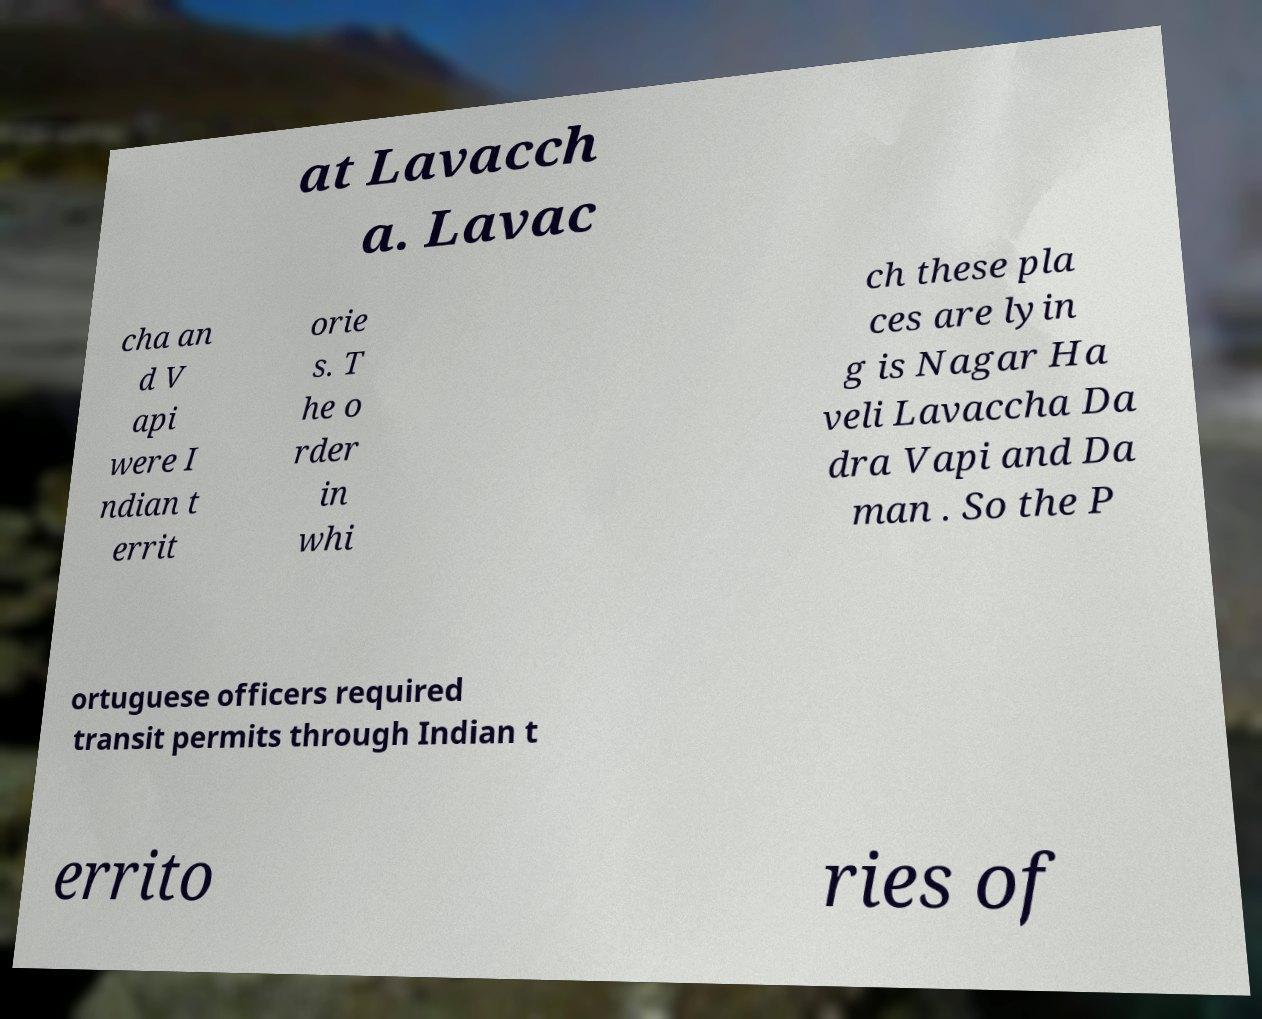For documentation purposes, I need the text within this image transcribed. Could you provide that? at Lavacch a. Lavac cha an d V api were I ndian t errit orie s. T he o rder in whi ch these pla ces are lyin g is Nagar Ha veli Lavaccha Da dra Vapi and Da man . So the P ortuguese officers required transit permits through Indian t errito ries of 